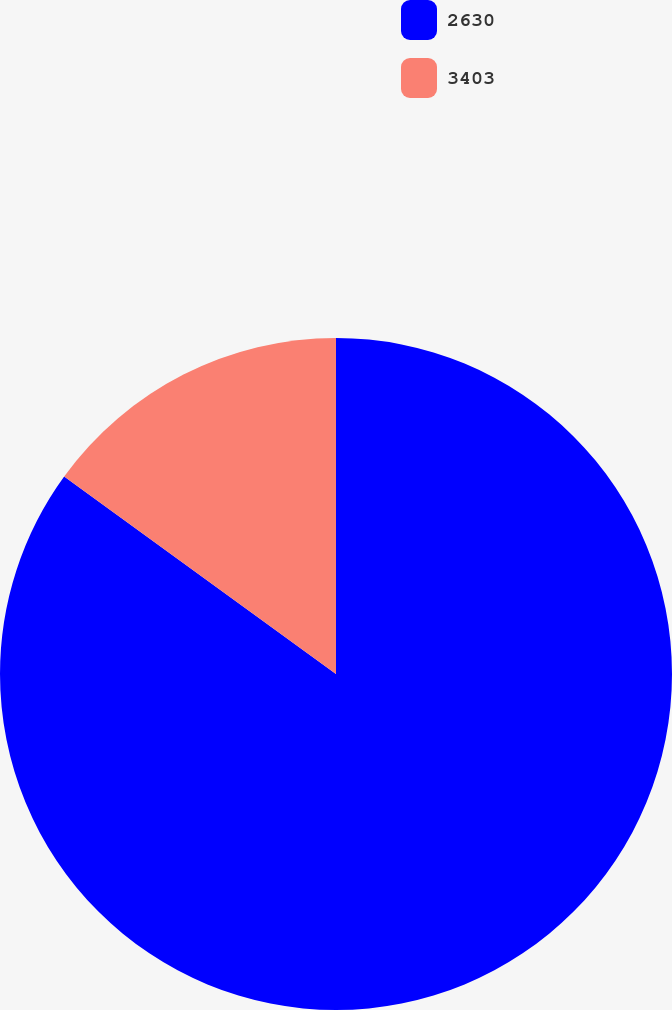<chart> <loc_0><loc_0><loc_500><loc_500><pie_chart><fcel>2630<fcel>3403<nl><fcel>85.0%<fcel>15.0%<nl></chart> 